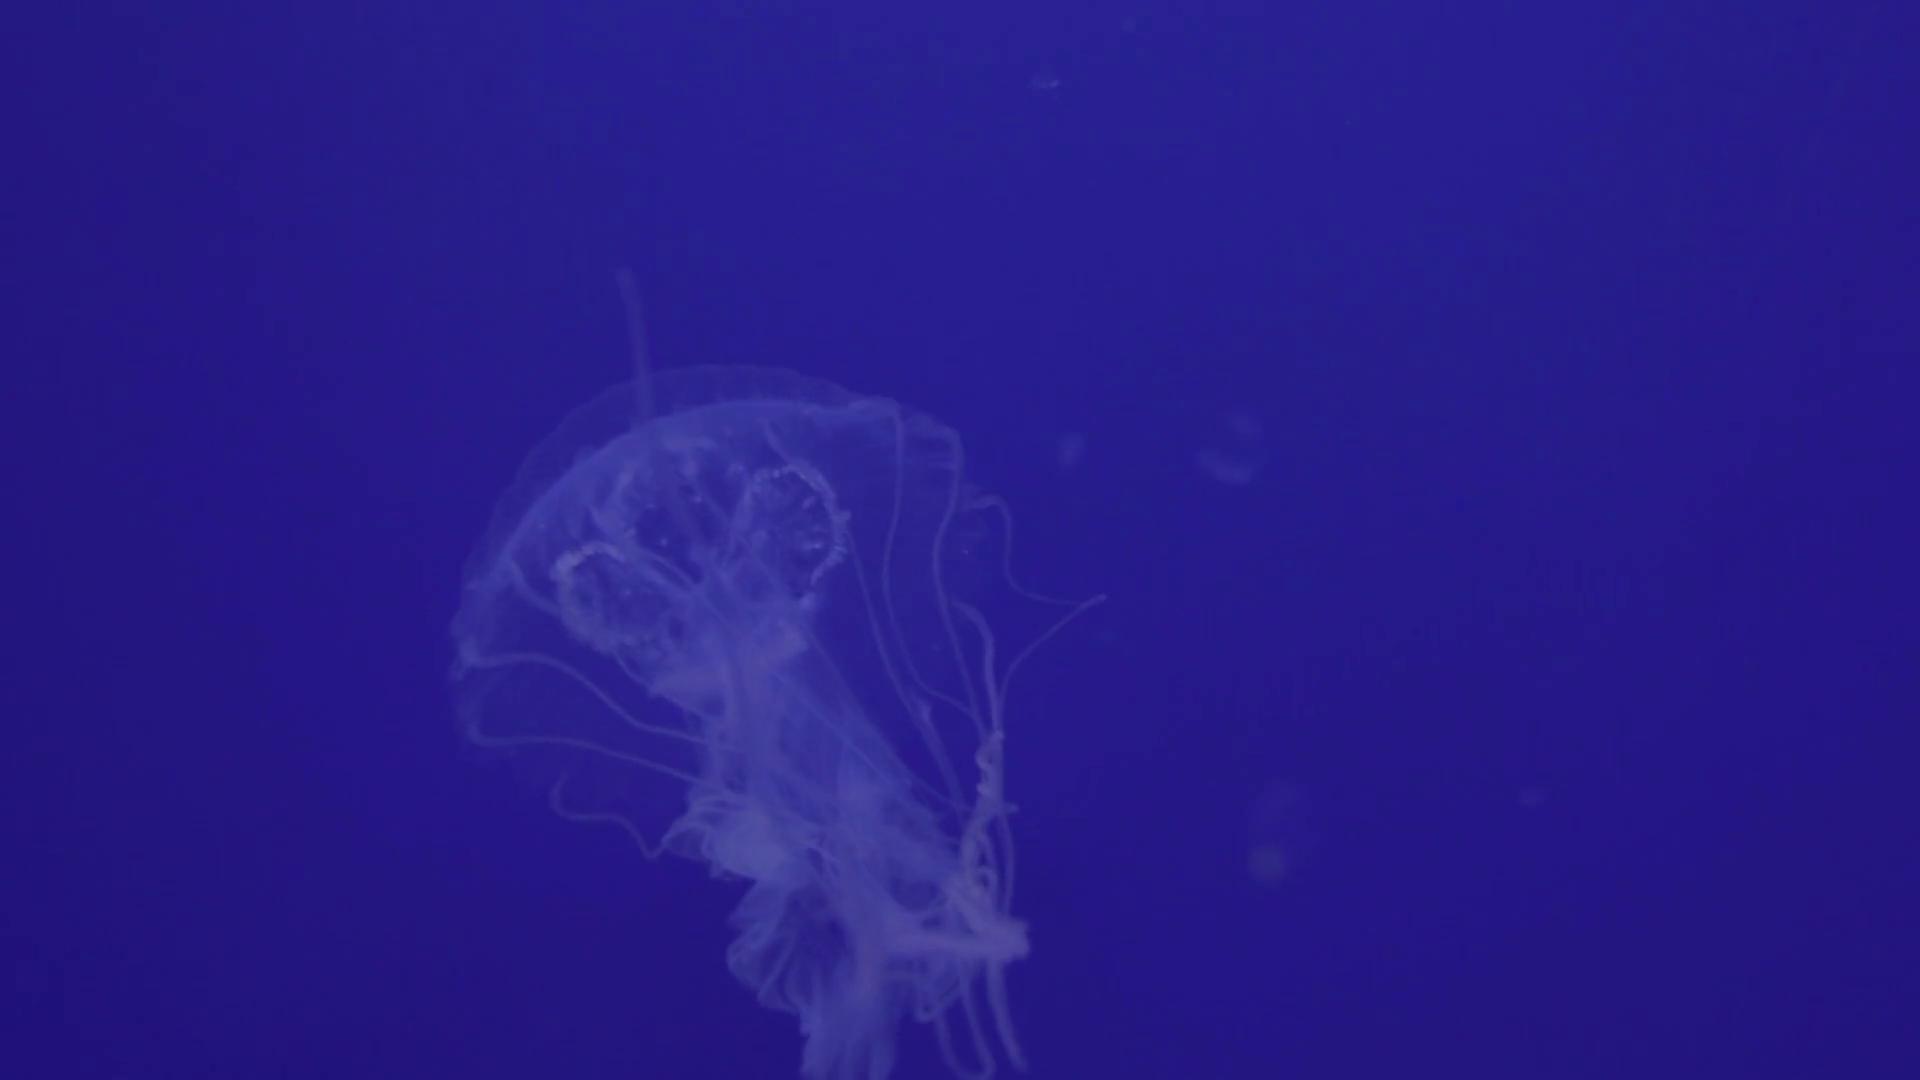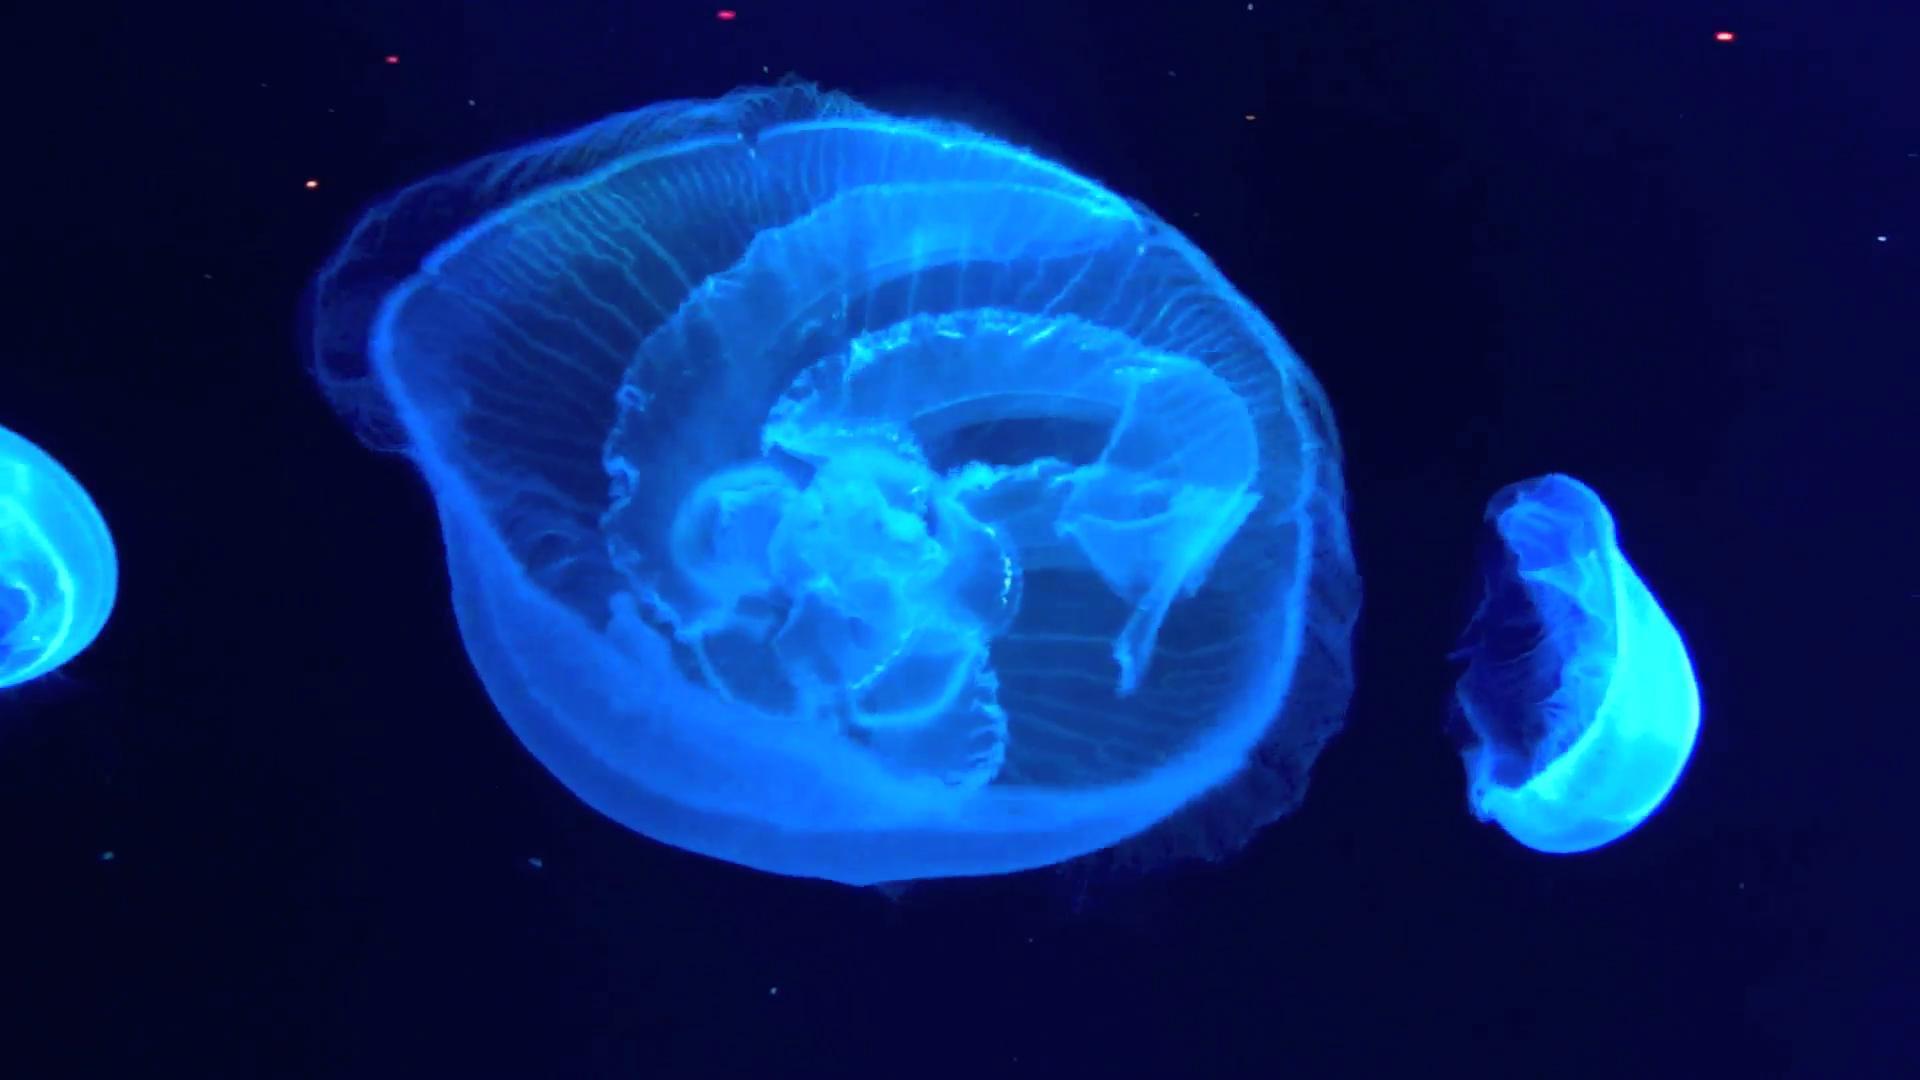The first image is the image on the left, the second image is the image on the right. Assess this claim about the two images: "In one image at least one jellyfish is upside down.". Correct or not? Answer yes or no. Yes. The first image is the image on the left, the second image is the image on the right. Analyze the images presented: Is the assertion "In at least one image there is a circle jellyfish with its head looking like a four leaf clover." valid? Answer yes or no. No. 